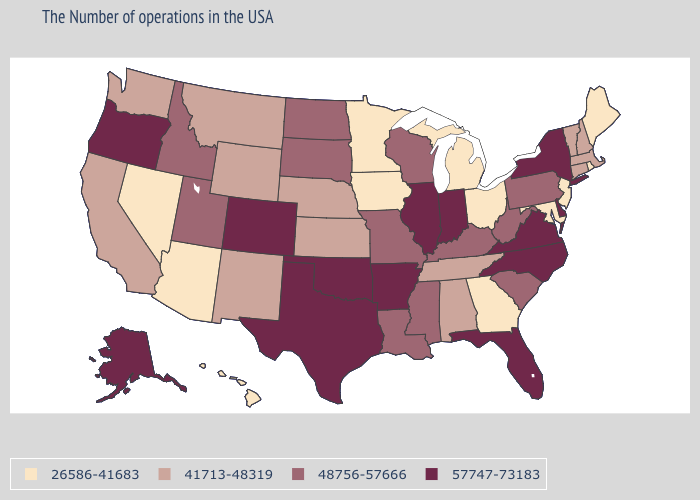What is the value of Washington?
Be succinct. 41713-48319. Name the states that have a value in the range 48756-57666?
Give a very brief answer. Pennsylvania, South Carolina, West Virginia, Kentucky, Wisconsin, Mississippi, Louisiana, Missouri, South Dakota, North Dakota, Utah, Idaho. Does Tennessee have a higher value than Iowa?
Write a very short answer. Yes. What is the value of Alaska?
Be succinct. 57747-73183. What is the value of Tennessee?
Concise answer only. 41713-48319. What is the value of North Dakota?
Answer briefly. 48756-57666. Which states have the highest value in the USA?
Answer briefly. New York, Delaware, Virginia, North Carolina, Florida, Indiana, Illinois, Arkansas, Oklahoma, Texas, Colorado, Oregon, Alaska. Which states have the lowest value in the West?
Be succinct. Arizona, Nevada, Hawaii. What is the highest value in states that border Indiana?
Concise answer only. 57747-73183. Does Florida have the highest value in the USA?
Give a very brief answer. Yes. Does Kansas have a higher value than North Dakota?
Answer briefly. No. What is the value of New York?
Concise answer only. 57747-73183. Does Arkansas have the highest value in the South?
Write a very short answer. Yes. Name the states that have a value in the range 48756-57666?
Keep it brief. Pennsylvania, South Carolina, West Virginia, Kentucky, Wisconsin, Mississippi, Louisiana, Missouri, South Dakota, North Dakota, Utah, Idaho. Name the states that have a value in the range 48756-57666?
Answer briefly. Pennsylvania, South Carolina, West Virginia, Kentucky, Wisconsin, Mississippi, Louisiana, Missouri, South Dakota, North Dakota, Utah, Idaho. 